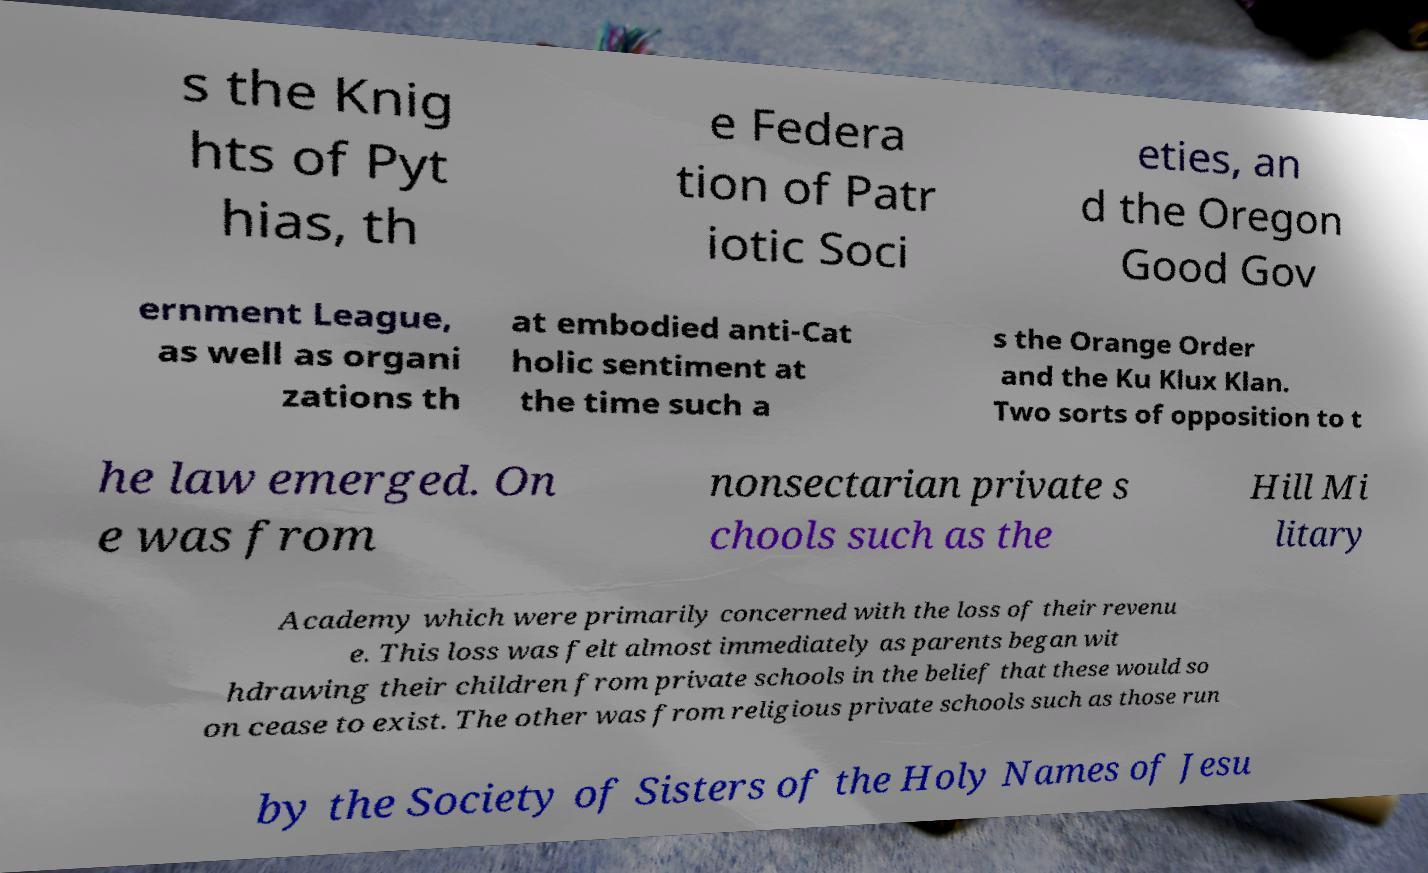What messages or text are displayed in this image? I need them in a readable, typed format. s the Knig hts of Pyt hias, th e Federa tion of Patr iotic Soci eties, an d the Oregon Good Gov ernment League, as well as organi zations th at embodied anti-Cat holic sentiment at the time such a s the Orange Order and the Ku Klux Klan. Two sorts of opposition to t he law emerged. On e was from nonsectarian private s chools such as the Hill Mi litary Academy which were primarily concerned with the loss of their revenu e. This loss was felt almost immediately as parents began wit hdrawing their children from private schools in the belief that these would so on cease to exist. The other was from religious private schools such as those run by the Society of Sisters of the Holy Names of Jesu 